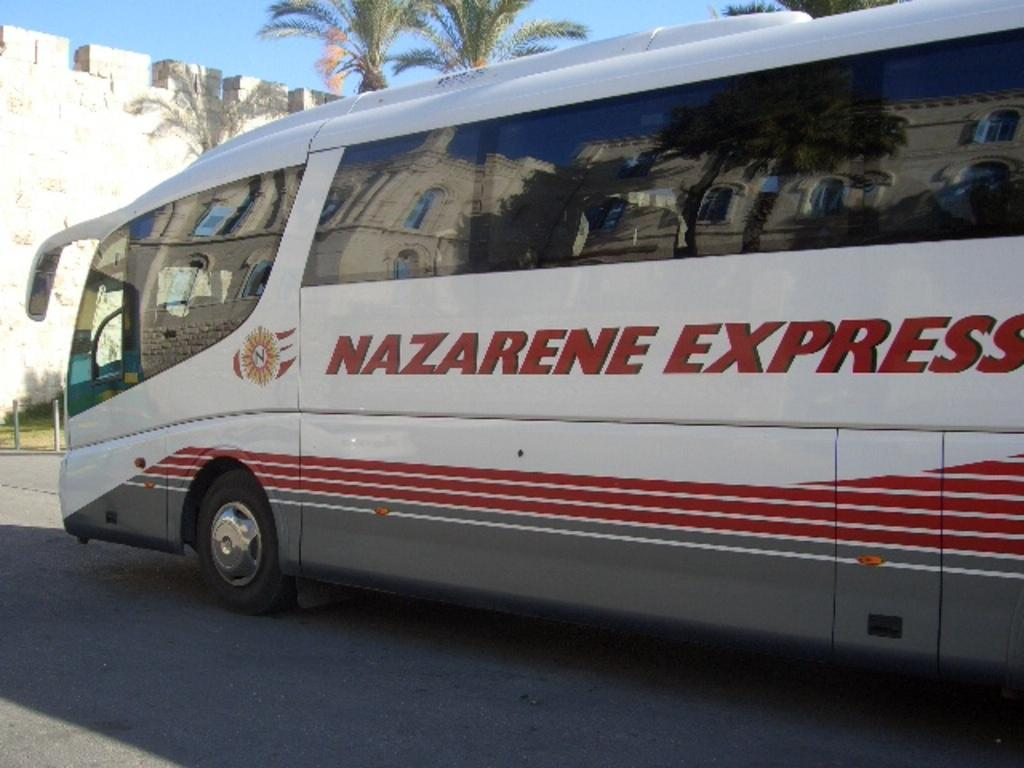<image>
Create a compact narrative representing the image presented. a bus with red lettering on the side that says 'nazarene express' 